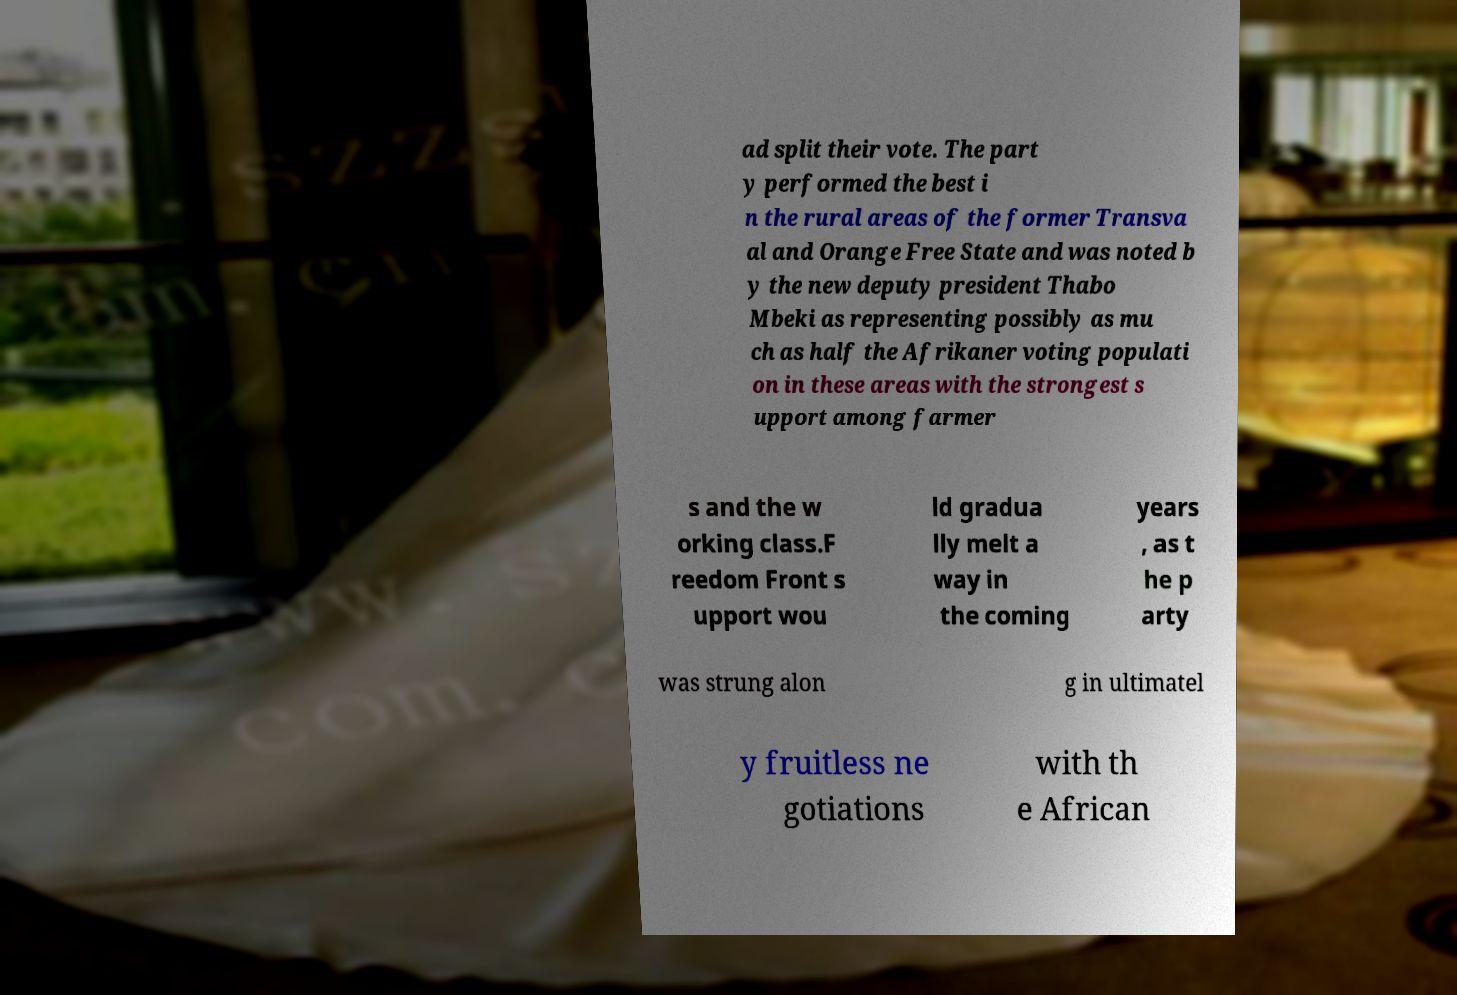Please read and relay the text visible in this image. What does it say? ad split their vote. The part y performed the best i n the rural areas of the former Transva al and Orange Free State and was noted b y the new deputy president Thabo Mbeki as representing possibly as mu ch as half the Afrikaner voting populati on in these areas with the strongest s upport among farmer s and the w orking class.F reedom Front s upport wou ld gradua lly melt a way in the coming years , as t he p arty was strung alon g in ultimatel y fruitless ne gotiations with th e African 